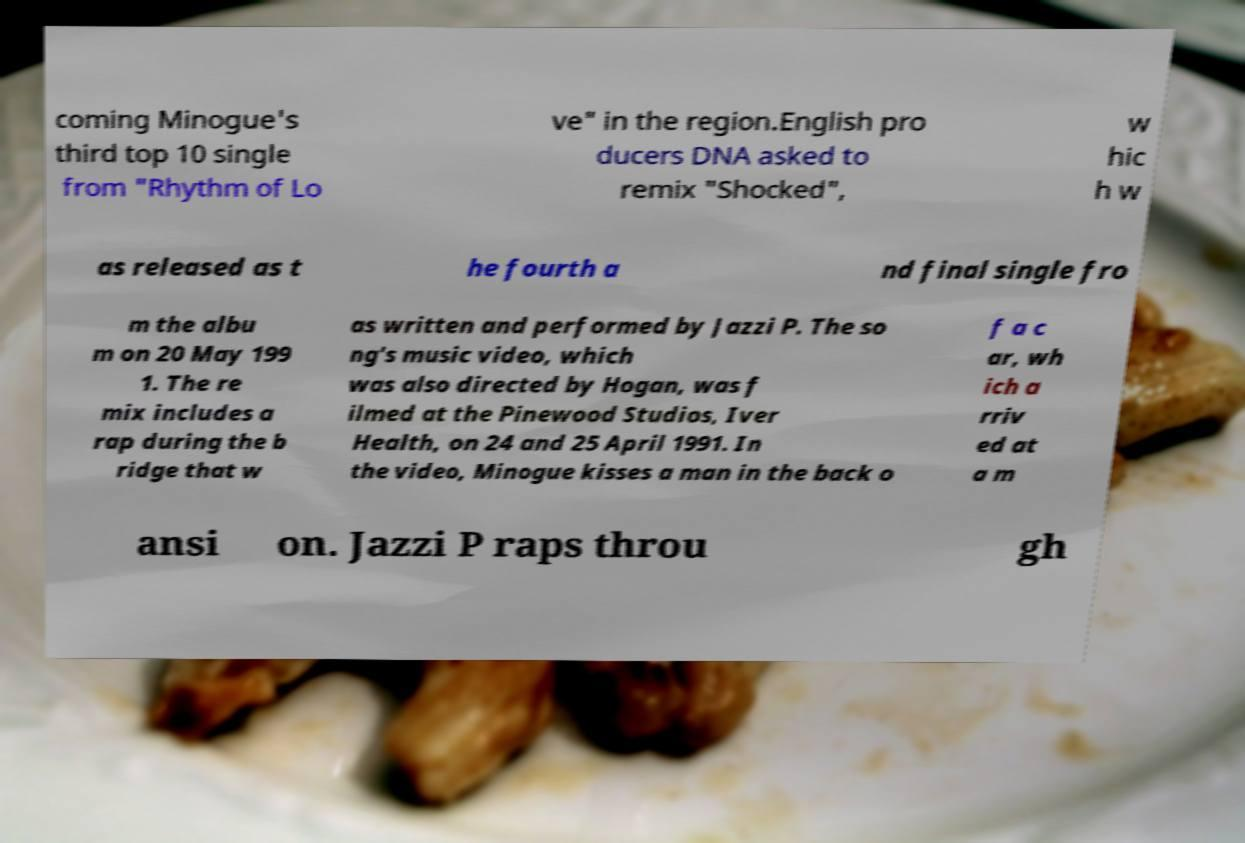Could you assist in decoding the text presented in this image and type it out clearly? coming Minogue's third top 10 single from "Rhythm of Lo ve" in the region.English pro ducers DNA asked to remix "Shocked", w hic h w as released as t he fourth a nd final single fro m the albu m on 20 May 199 1. The re mix includes a rap during the b ridge that w as written and performed by Jazzi P. The so ng's music video, which was also directed by Hogan, was f ilmed at the Pinewood Studios, Iver Health, on 24 and 25 April 1991. In the video, Minogue kisses a man in the back o f a c ar, wh ich a rriv ed at a m ansi on. Jazzi P raps throu gh 